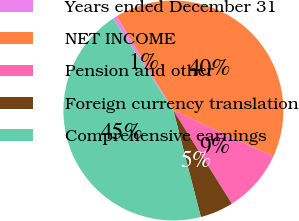<chart> <loc_0><loc_0><loc_500><loc_500><pie_chart><fcel>Years ended December 31<fcel>NET INCOME<fcel>Pension and other<fcel>Foreign currency translation<fcel>Comprehensive earnings<nl><fcel>0.59%<fcel>40.49%<fcel>9.21%<fcel>4.9%<fcel>44.8%<nl></chart> 